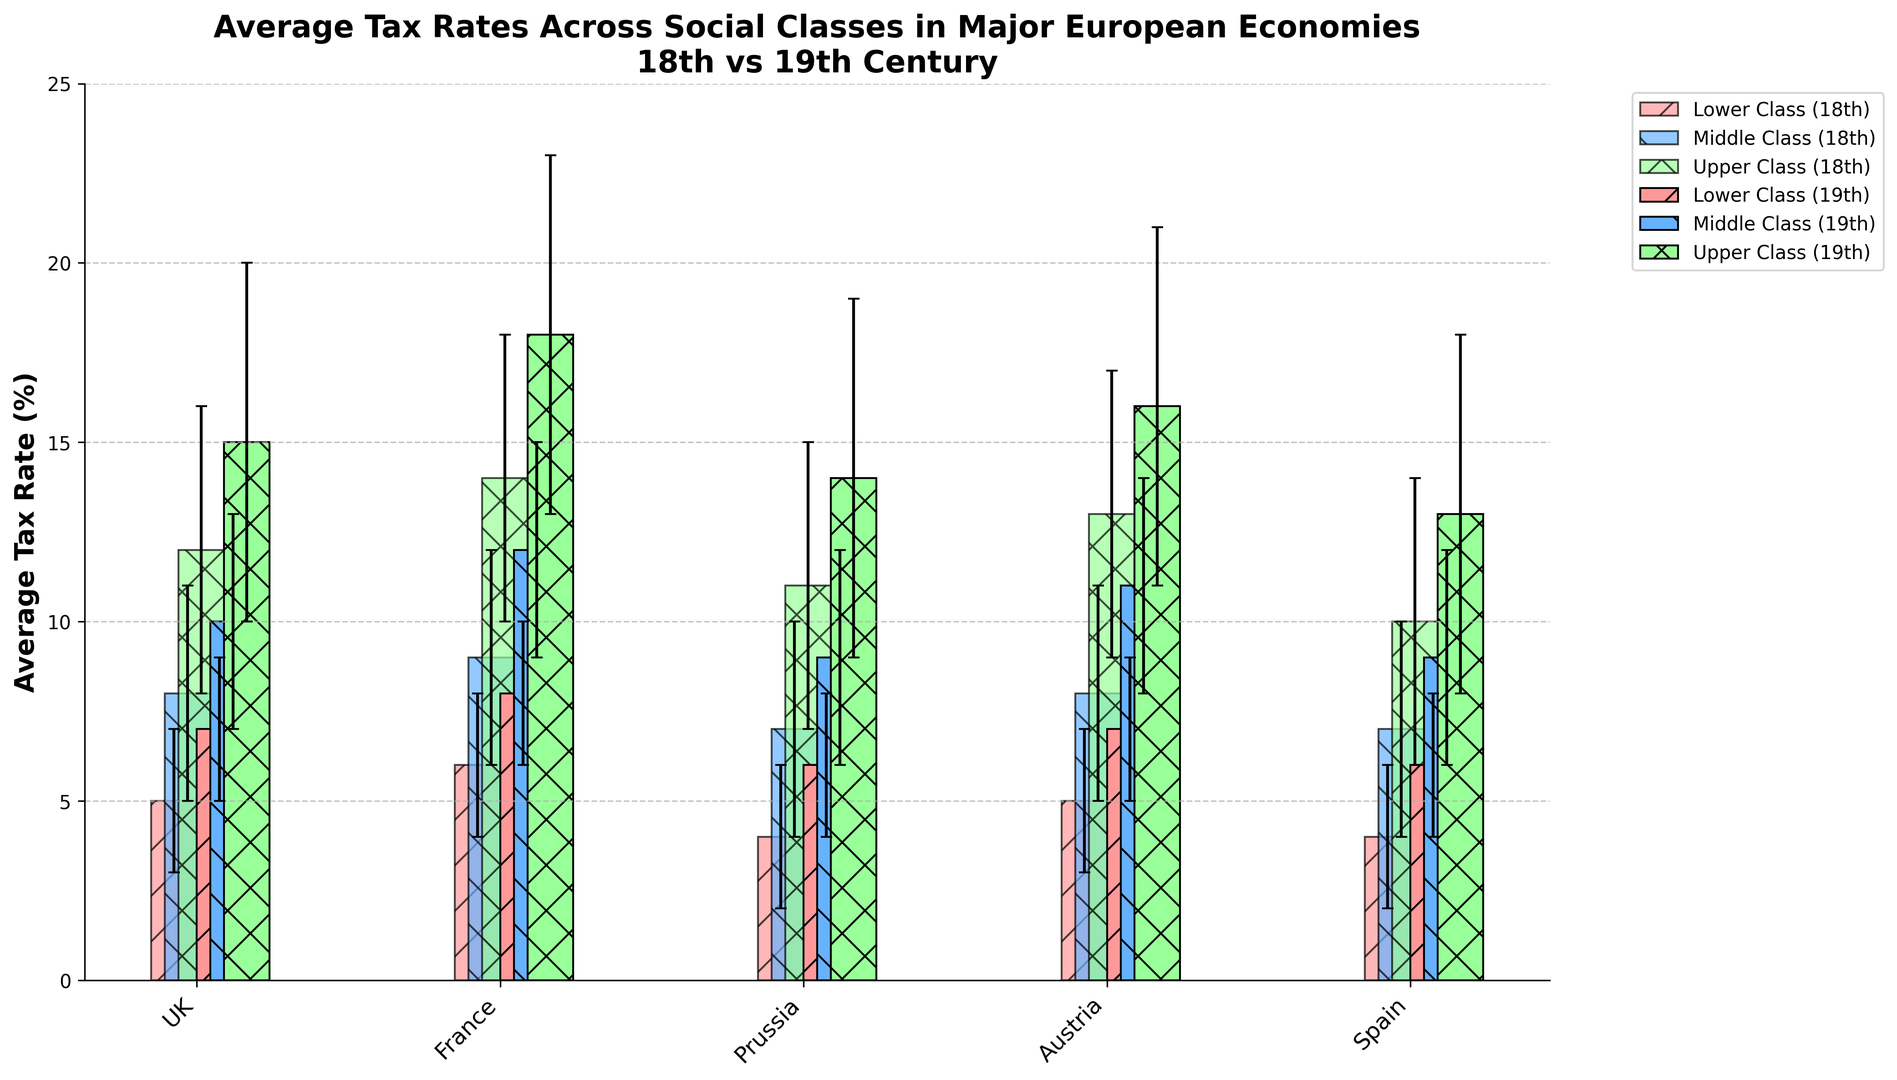What is the average tax rate for the Lower Class in the 18th century across all countries? To find the average tax rate for the Lower Class in the 18th century, sum the rates for each country (UK: 5, France: 6, Prussia: 4, Austria: 5, Spain: 4) and then divide by the number of countries, which is 5. (5+6+4+5+4) / 5 = 24 / 5 = 4.8
Answer: 4.8 Which country had the highest average tax rate for the Upper Class in the 19th century? Compare the average tax rates for the Upper Class in the 19th century across all countries. UK: 15, France: 18, Prussia: 14, Austria: 16, Spain: 13. The highest value is 18, which corresponds to France.
Answer: France How does the tax rate error margin for the Middle Class in Spain during the 18th century compare to that of the UK in the same period? The error margins for the Middle Class in the 18th century are UK: 3 and Spain: 3. Since both error margins are 3, they are equal.
Answer: Equal What is the difference in average tax rates for the Middle Class in France between the 18th and 19th centuries? Subtract the average tax rate of the Middle Class in France in the 18th century (9) from that in the 19th century (12). 12 - 9 = 3
Answer: 3 Compare the visual height of the bars for the Upper Class in the 19th century between the UK and Austria Visually inspect the height of the bars for the Upper Class in the 19th century for the UK and Austria. The bar for the UK reaches 15, while for Austria it reaches 16. Therefore, Austria's bar is taller.
Answer: Austria's bar is taller Which social class experienced the largest increase in average tax rate from the 18th to the 19th century in the UK? Calculate the changes in tax rates from the 18th to 19th centuries for each social class in the UK: Lower Class (7-5=2), Middle Class (10-8=2), Upper Class (15-12=3). The largest increase is for the Upper Class, which is 3.
Answer: Upper Class Is there any social class in any country where the tax rate decreased from the 18th to the 19th century? Review the average tax rates for each social class in each country from the 18th to the 19th century. None of the social classes in any country show a decrease in tax rate.
Answer: No What is the combined error margin for the Middle Class in both centuries in Austria? Sum the error margins for the Middle Class in Austria for the 18th century (3) and the 19th century (3). 3 + 3 = 6
Answer: 6 Which class has the smallest error margin for the 19th century in Spain? Compare the error margins for all classes in Spain for the 19th century: Lower Class (2), Middle Class (3), Upper Class (5). The smallest error margin is 2, which corresponds to the Lower Class.
Answer: Lower Class How many countries have a higher average tax rate for the Middle Class in the 19th century than in the 18th century? Compare the average tax rates for the Middle Class in the 18th and 19th centuries across all countries. UK: increased (10 > 8), France: increased (12 > 9), Prussia: increased (9 > 7), Austria: increased (11 > 8), Spain: increased (9 > 7). All 5 countries had an increase.
Answer: 5 